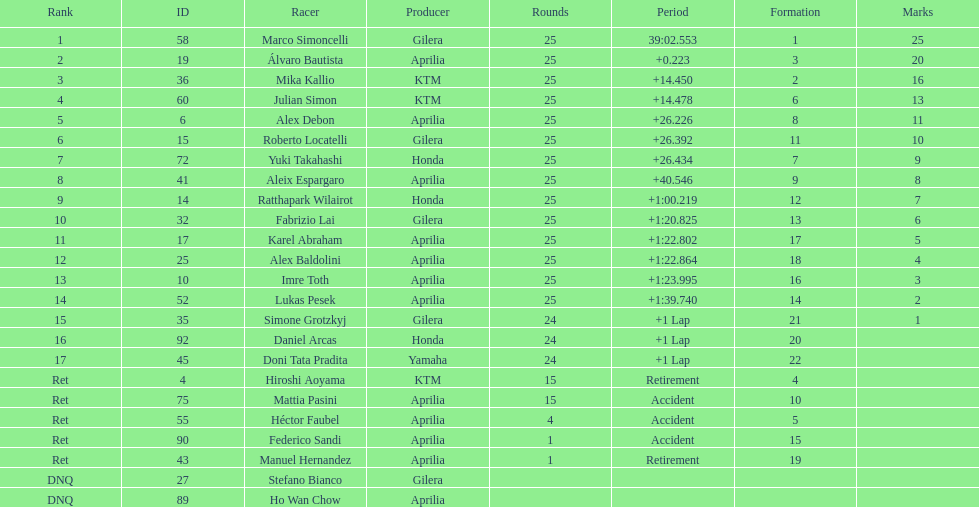What is the total number of rider? 24. 